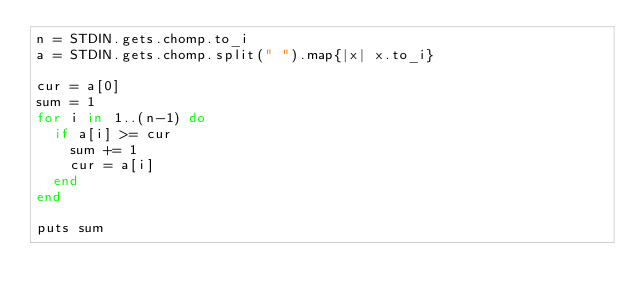<code> <loc_0><loc_0><loc_500><loc_500><_Ruby_>n = STDIN.gets.chomp.to_i
a = STDIN.gets.chomp.split(" ").map{|x| x.to_i}

cur = a[0]
sum = 1
for i in 1..(n-1) do
  if a[i] >= cur
    sum += 1
    cur = a[i]
  end
end

puts sum</code> 